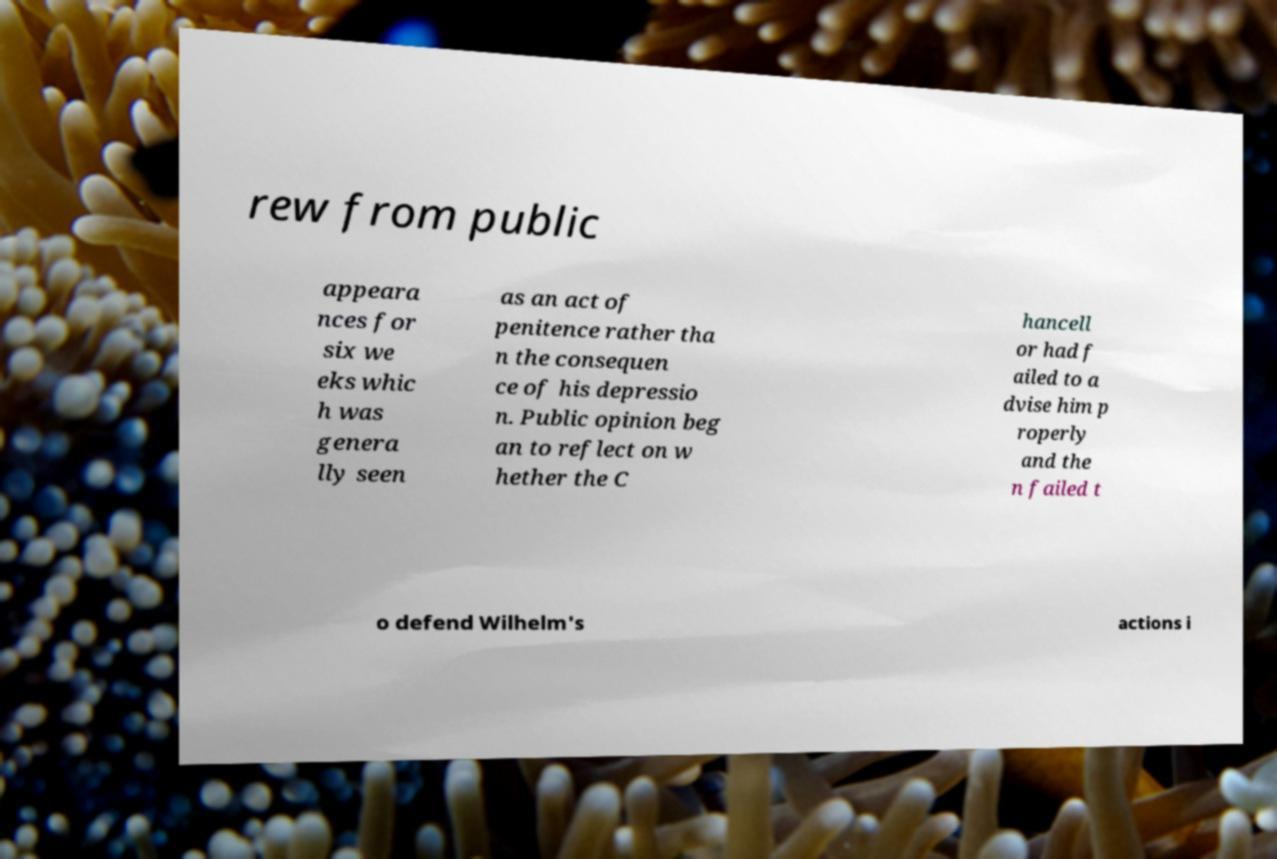Please read and relay the text visible in this image. What does it say? rew from public appeara nces for six we eks whic h was genera lly seen as an act of penitence rather tha n the consequen ce of his depressio n. Public opinion beg an to reflect on w hether the C hancell or had f ailed to a dvise him p roperly and the n failed t o defend Wilhelm's actions i 